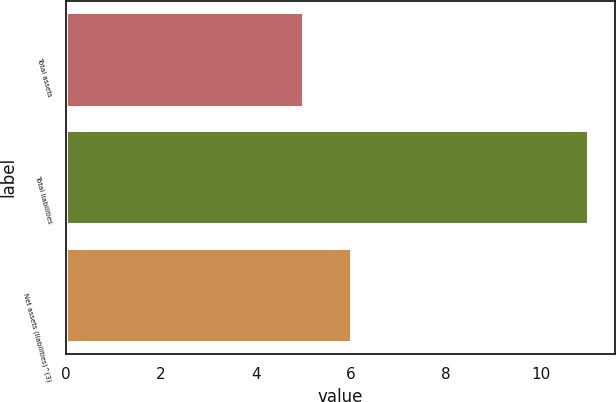<chart> <loc_0><loc_0><loc_500><loc_500><bar_chart><fcel>Total assets<fcel>Total liabilities<fcel>Net assets (liabilities)^(3)<nl><fcel>5<fcel>11<fcel>6<nl></chart> 